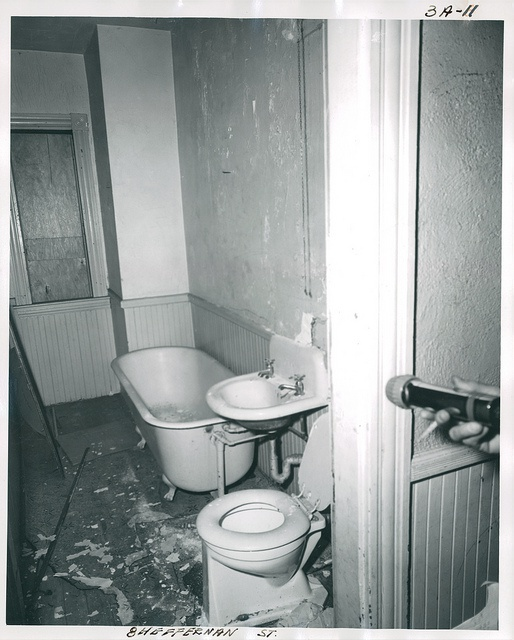Describe the objects in this image and their specific colors. I can see toilet in lightgray, darkgray, and gray tones, sink in lightgray, darkgray, and gray tones, and people in lightgray, darkgray, black, and gray tones in this image. 